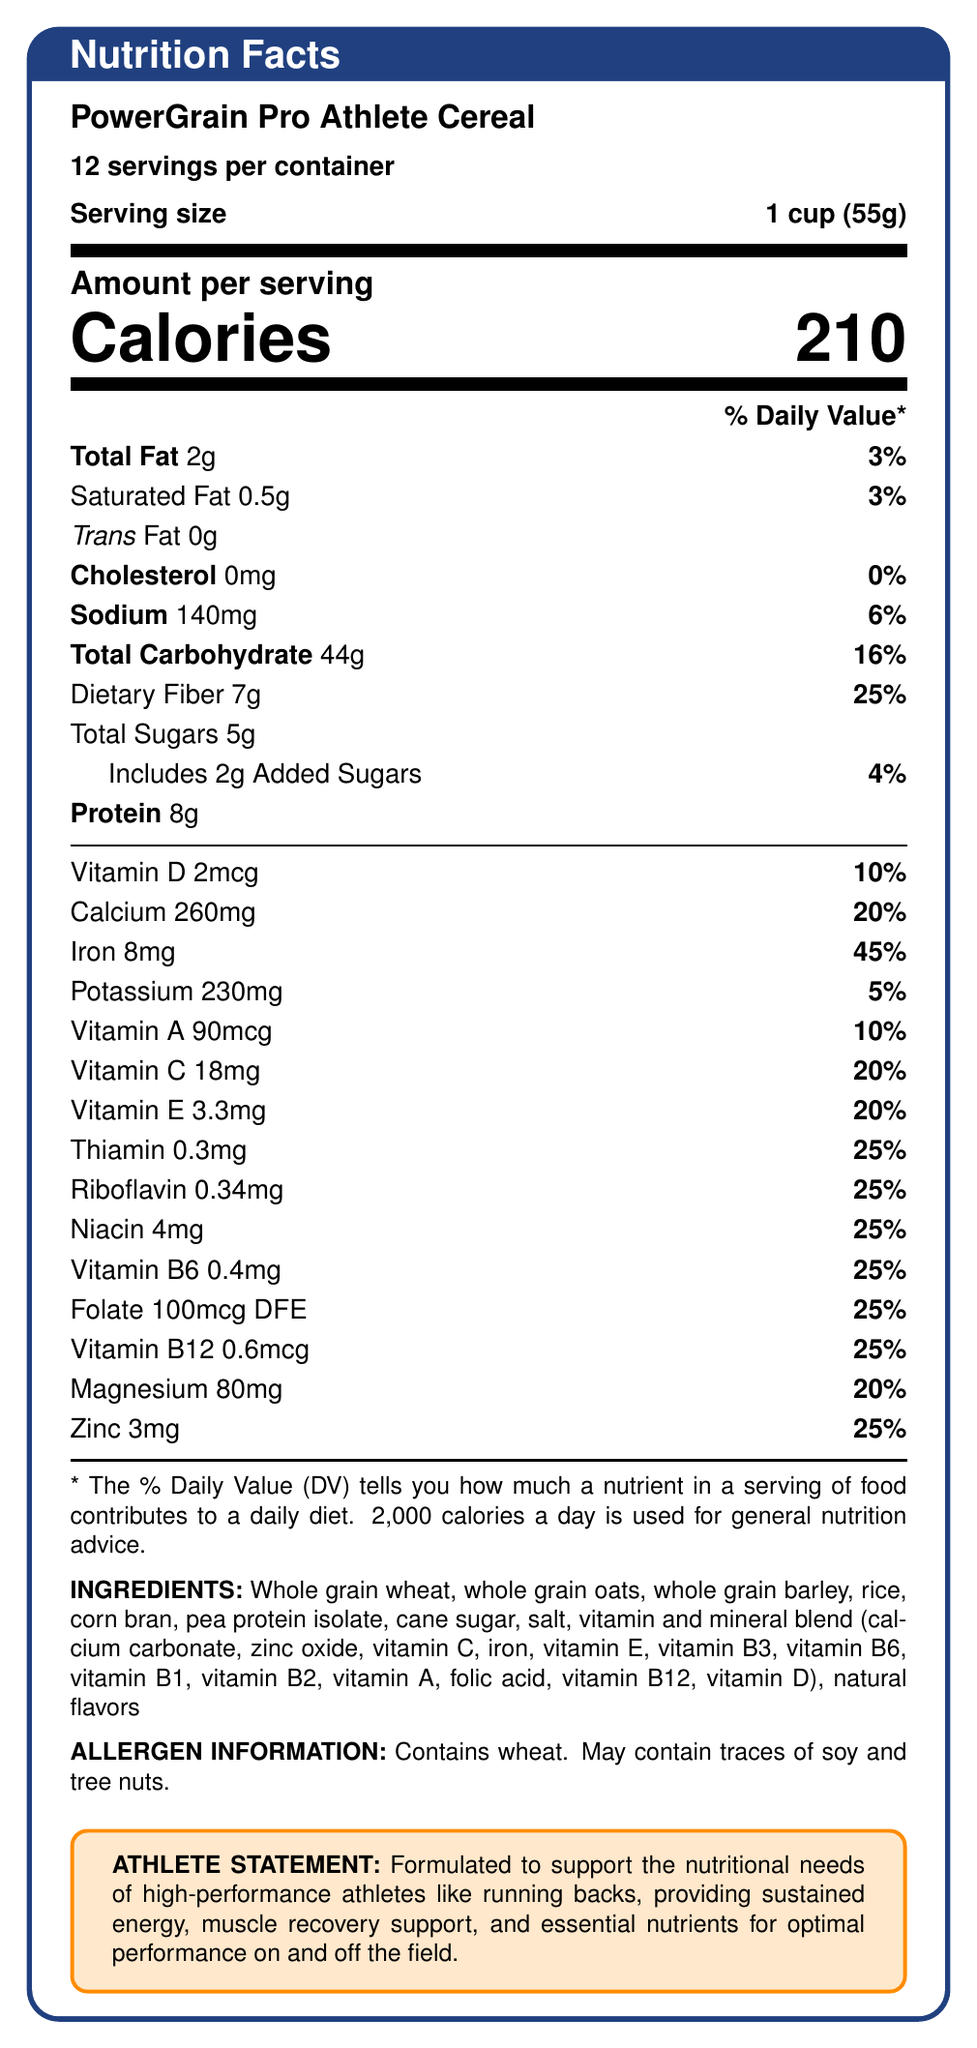what is the serving size of PowerGrain Pro Athlete Cereal? The serving size is clearly stated near the top of the document: "Serving size: 1 cup (55g)".
Answer: 1 cup (55g) How many calories are in one serving of this cereal? The number of calories per serving is highlighted in large font in the document: "Calories 210".
Answer: 210 calories What is the percentage of Daily Value for Iron in one serving? The document lists Iron as contributing 45% of the Daily Value per serving.
Answer: 45% How much dietary fiber is in one serving? The dietary fiber content per serving is listed as "Dietary Fiber 7g" in the document.
Answer: 7g How much protein is there in one serving of the cereal? The protein content per serving is noted as "Protein 8g".
Answer: 8g What is the percentage of Daily Value for Vitamin D in one serving? A. 5% B. 10% C. 20% The Daily Value percentage for Vitamin D is specified as 10%.
Answer: B. 10% Which of the following nutrients does the cereal contain the most of by weight? A. Saturated Fat B. Sodium C. Dietary Fiber By weight, the cereal contains the most dietary fiber (7g) compared to saturated fat (0.5g) and sodium (140mg ≈ 0.14g).
Answer: C. Dietary Fiber Does the cereal contain any added sugars? The document lists "Includes 2g Added Sugars".
Answer: Yes Is this cereal a good source of Vitamin C? The cereal provides 20% of the Daily Value for Vitamin C, which is generally considered a good source.
Answer: Yes Summarize the main nutritional benefits of PowerGrain Pro Athlete Cereal. This summary covers the key nutritional benefits and goals of the cereal as described in the document, emphasizing the nutrient content and focus on athletes.
Answer: PowerGrain Pro Athlete Cereal provides a balanced mix of essential nutrients and vitamins. It is high in fiber (25% DV), iron (45% DV), and includes protein (8g) to support muscle recovery. The cereal is formulated particularly for high-performance athletes, offering sustained energy and essential nutrients. What is the full ingredient list of PowerGrain Pro Athlete Cereal? The ingredients are listed towards the end of the document under the "INGREDIENTS" section.
Answer: Whole grain wheat, whole grain oats, whole grain barley, rice, corn bran, pea protein isolate, cane sugar, salt, vitamin and mineral blend (calcium carbonate, zinc oxide, vitamin C, iron, vitamin E, vitamin B3, vitamin B6, vitamin B1, vitamin B2, vitamin A, folic acid, vitamin B12, vitamin D), natural flavors What potential allergens are mentioned for this cereal? The allergen statement specifies that the cereal contains wheat and may contain traces of soy and tree nuts.
Answer: Contains wheat. May contain traces of soy and tree nuts. How much calcium is in one serving, and what percentage of the Daily Value does it represent? The document states: "Calcium 260mg \hfill 20%”.
Answer: 260mg, 20% How many servings are there per container? The number of servings per container is clearly indicated near the top of the document: "12 servings per container".
Answer: 12 Does this cereal contain trans fat? The document specifies "Trans Fat 0g".
Answer: No What is the role of this cereal according to the Athlete Statement? The Athlete Statement describes the cereal’s role in supporting the nutritional needs of high-performance athletes.
Answer: Provides sustained energy, muscle recovery support, and essential nutrients for optimal performance on and off the field. How much Vitamin B12 is present in one serving? The document states "Vitamin B12 0.6mcg \hfill 25%”.
Answer: 0.6mcg Is the cereal high in sodium? The sodium content is 140mg per serving, which is 6% of the Daily Value and not typically considered high.
Answer: No What is the percentage of Daily Value for Zinc in each serving? The document lists Zinc as providing 25% of the Daily Value per serving.
Answer: 25% Are there artificial flavors in this cereal? The document lists "natural flavors" but does not provide information about the presence or absence of artificial flavors.
Answer: Not enough information 